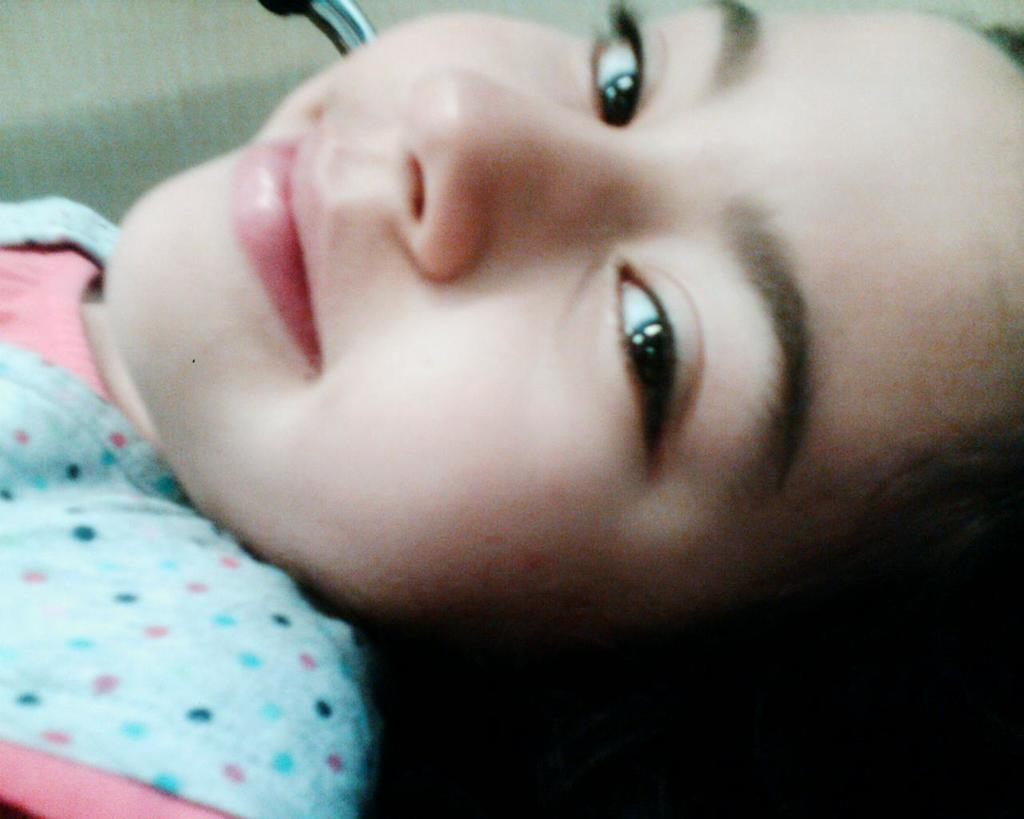What is the main subject of the image? There is a person in the image. What can be seen behind the person in the image? There is a background visible in the image. Is there any object present at the top of the image? Yes, there is an object on the top of the image. What type of chain can be seen hanging from the person's neck in the image? There is no chain visible hanging from the person's neck in the image. What reason is given for the person's presence in the image? There is no specific reason provided for the person's presence in the image. 